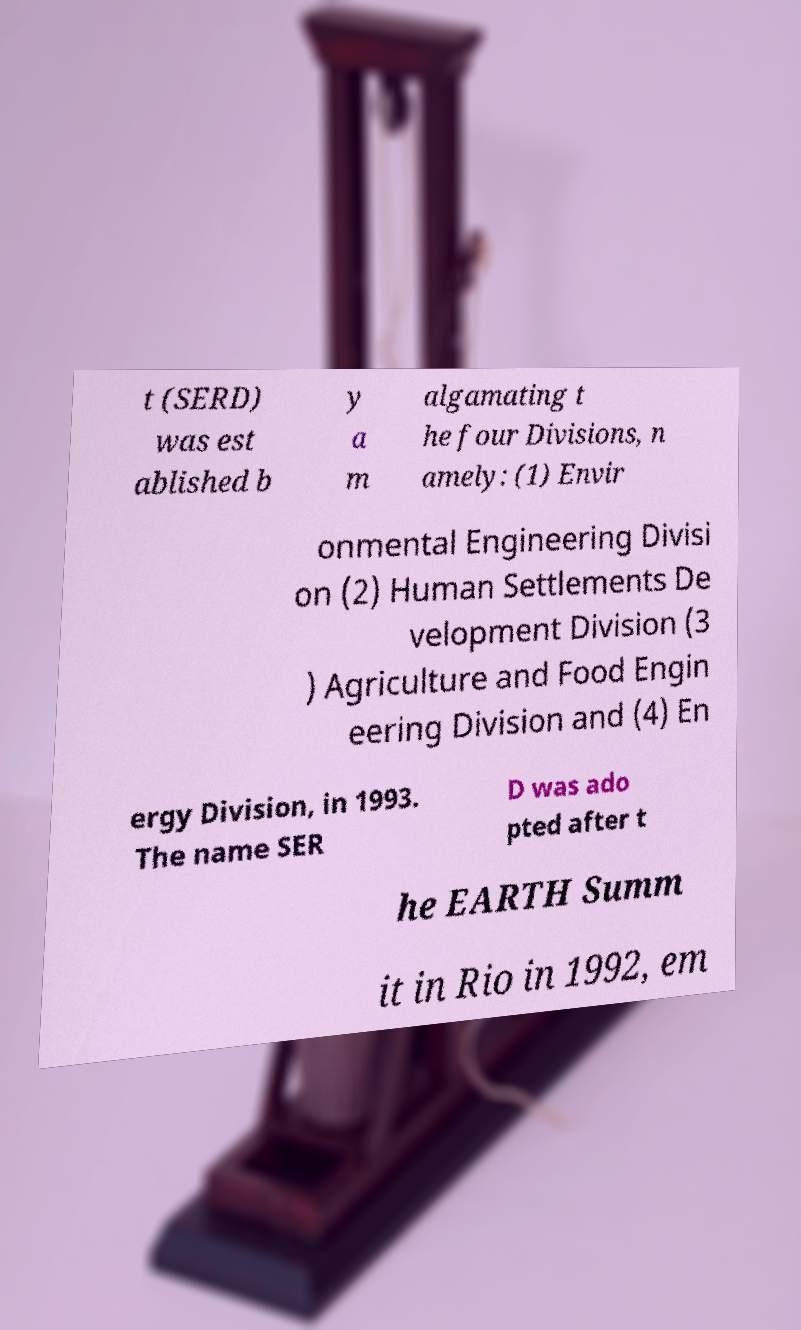I need the written content from this picture converted into text. Can you do that? t (SERD) was est ablished b y a m algamating t he four Divisions, n amely: (1) Envir onmental Engineering Divisi on (2) Human Settlements De velopment Division (3 ) Agriculture and Food Engin eering Division and (4) En ergy Division, in 1993. The name SER D was ado pted after t he EARTH Summ it in Rio in 1992, em 